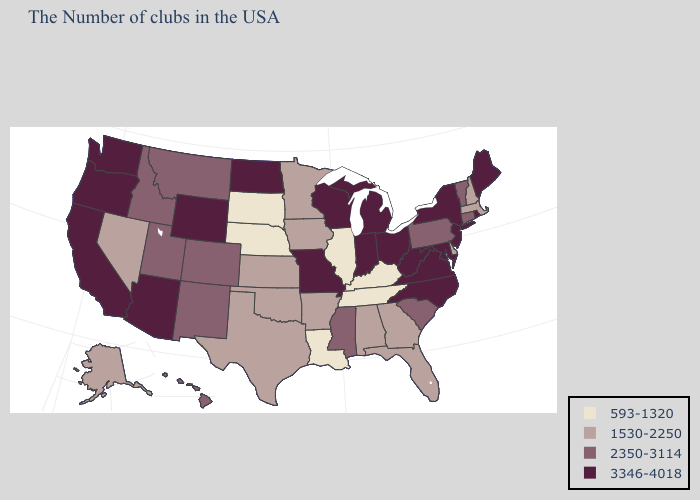What is the value of Connecticut?
Write a very short answer. 2350-3114. Name the states that have a value in the range 3346-4018?
Quick response, please. Maine, Rhode Island, New York, New Jersey, Maryland, Virginia, North Carolina, West Virginia, Ohio, Michigan, Indiana, Wisconsin, Missouri, North Dakota, Wyoming, Arizona, California, Washington, Oregon. Is the legend a continuous bar?
Concise answer only. No. Does Michigan have a higher value than Washington?
Quick response, please. No. What is the highest value in the USA?
Write a very short answer. 3346-4018. What is the value of Oklahoma?
Give a very brief answer. 1530-2250. What is the highest value in the USA?
Answer briefly. 3346-4018. Name the states that have a value in the range 2350-3114?
Answer briefly. Vermont, Connecticut, Pennsylvania, South Carolina, Mississippi, Colorado, New Mexico, Utah, Montana, Idaho, Hawaii. What is the highest value in the South ?
Short answer required. 3346-4018. What is the lowest value in states that border Alabama?
Be succinct. 593-1320. What is the highest value in states that border Connecticut?
Short answer required. 3346-4018. Among the states that border North Carolina , which have the highest value?
Keep it brief. Virginia. What is the highest value in the MidWest ?
Be succinct. 3346-4018. Name the states that have a value in the range 1530-2250?
Answer briefly. Massachusetts, New Hampshire, Delaware, Florida, Georgia, Alabama, Arkansas, Minnesota, Iowa, Kansas, Oklahoma, Texas, Nevada, Alaska. Which states have the lowest value in the South?
Concise answer only. Kentucky, Tennessee, Louisiana. 